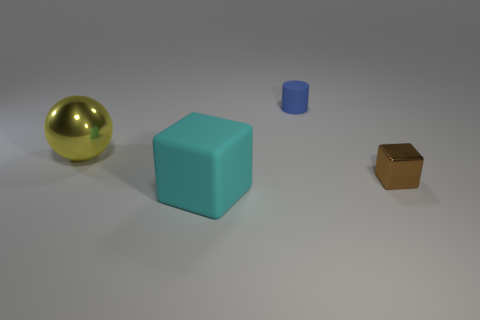What shape is the shiny thing that is the same size as the rubber block?
Give a very brief answer. Sphere. What number of objects are tiny objects that are behind the brown metal cube or things that are behind the big matte cube?
Offer a terse response. 3. Is the number of purple metal cubes less than the number of cyan rubber objects?
Provide a succinct answer. Yes. There is a cube that is the same size as the blue cylinder; what is it made of?
Provide a succinct answer. Metal. Do the object that is behind the large yellow thing and the block that is behind the cyan rubber object have the same size?
Offer a very short reply. Yes. Are there any other small objects that have the same material as the yellow object?
Offer a very short reply. Yes. What number of objects are either rubber things behind the big cyan rubber block or cyan matte objects?
Provide a short and direct response. 2. Does the big cyan cube that is right of the yellow metallic ball have the same material as the blue cylinder?
Give a very brief answer. Yes. Is the big yellow metal thing the same shape as the small shiny object?
Give a very brief answer. No. How many blue matte things are behind the small object that is behind the yellow metal sphere?
Provide a succinct answer. 0. 